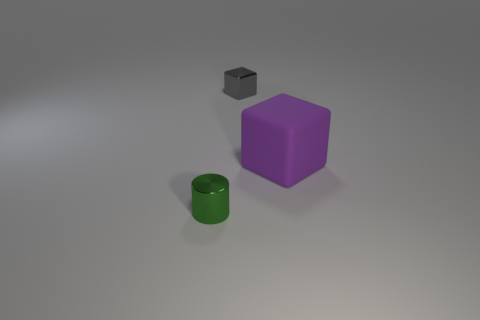What is the arrangement of these objects in terms of proximity? The objects are placed with a moderate distance between each other, forming a small cluster on a flat surface. The purple cube is positioned centrally, with the green cylinder in front and the gray cube slightly behind, indicating a casual, unstructured arrangement.  Do the shadows suggest a specific light source direction? Yes, the shadows of the objects extend towards the bottom right corner of the image, indicating that the light source is to the top left of the scene. 